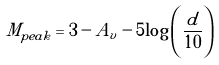Convert formula to latex. <formula><loc_0><loc_0><loc_500><loc_500>M _ { p e a k } = 3 - A _ { v } - 5 { \log } \left ( \frac { d } { 1 0 } \right )</formula> 